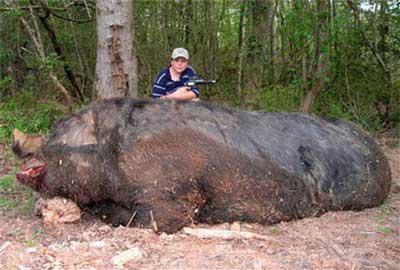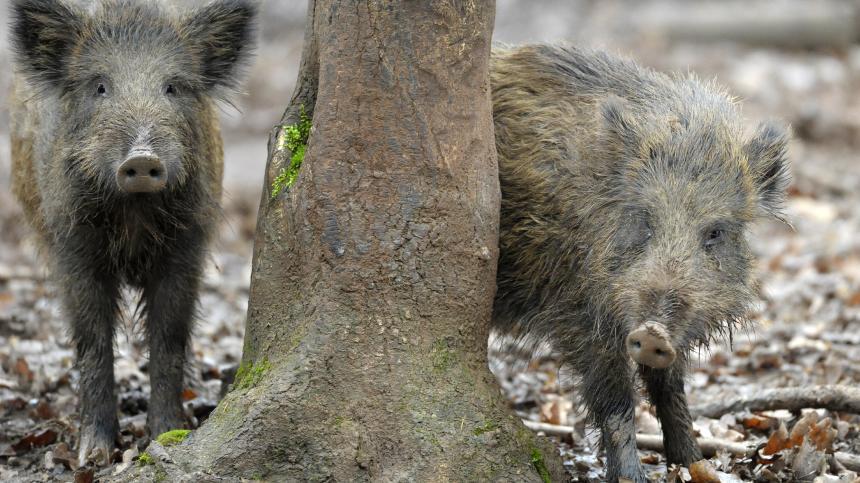The first image is the image on the left, the second image is the image on the right. Given the left and right images, does the statement "The right image contains exactly two pigs." hold true? Answer yes or no. Yes. The first image is the image on the left, the second image is the image on the right. Evaluate the accuracy of this statement regarding the images: "The combined images contain three pigs, and the right image contains twice as many pigs as the left image.". Is it true? Answer yes or no. Yes. 